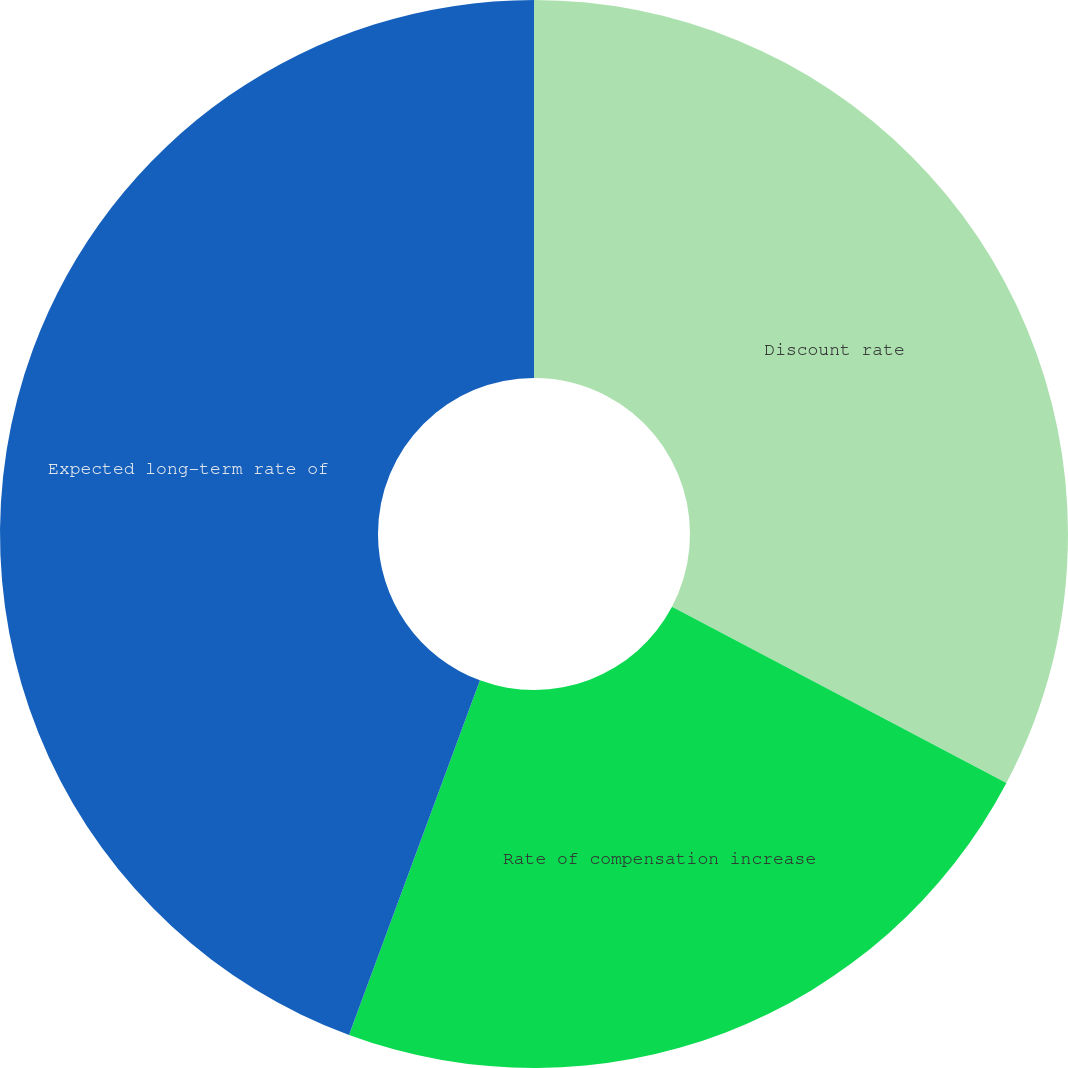<chart> <loc_0><loc_0><loc_500><loc_500><pie_chart><fcel>Discount rate<fcel>Rate of compensation increase<fcel>Expected long-term rate of<nl><fcel>32.72%<fcel>22.91%<fcel>44.37%<nl></chart> 